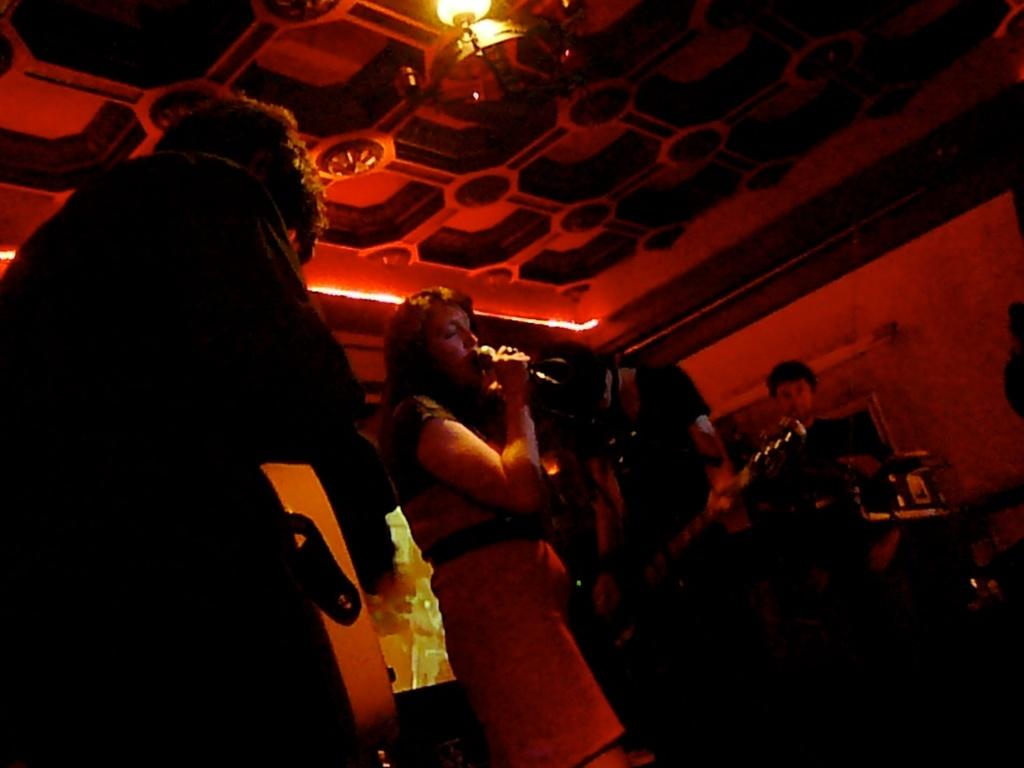How many people are in the image? There are four persons in the image. What are two of the persons holding? One person is holding a microphone, and another person is holding a guitar. What can be seen in the background of the image? There is a wall visible in the image. What is present on the ceiling in the image? There are lights on the ceiling. What type of calculator is being used by the person in the image? There is no calculator present in the image. What fictional character is the person dressed as in the image? There is no indication of a fictional character in the image. 